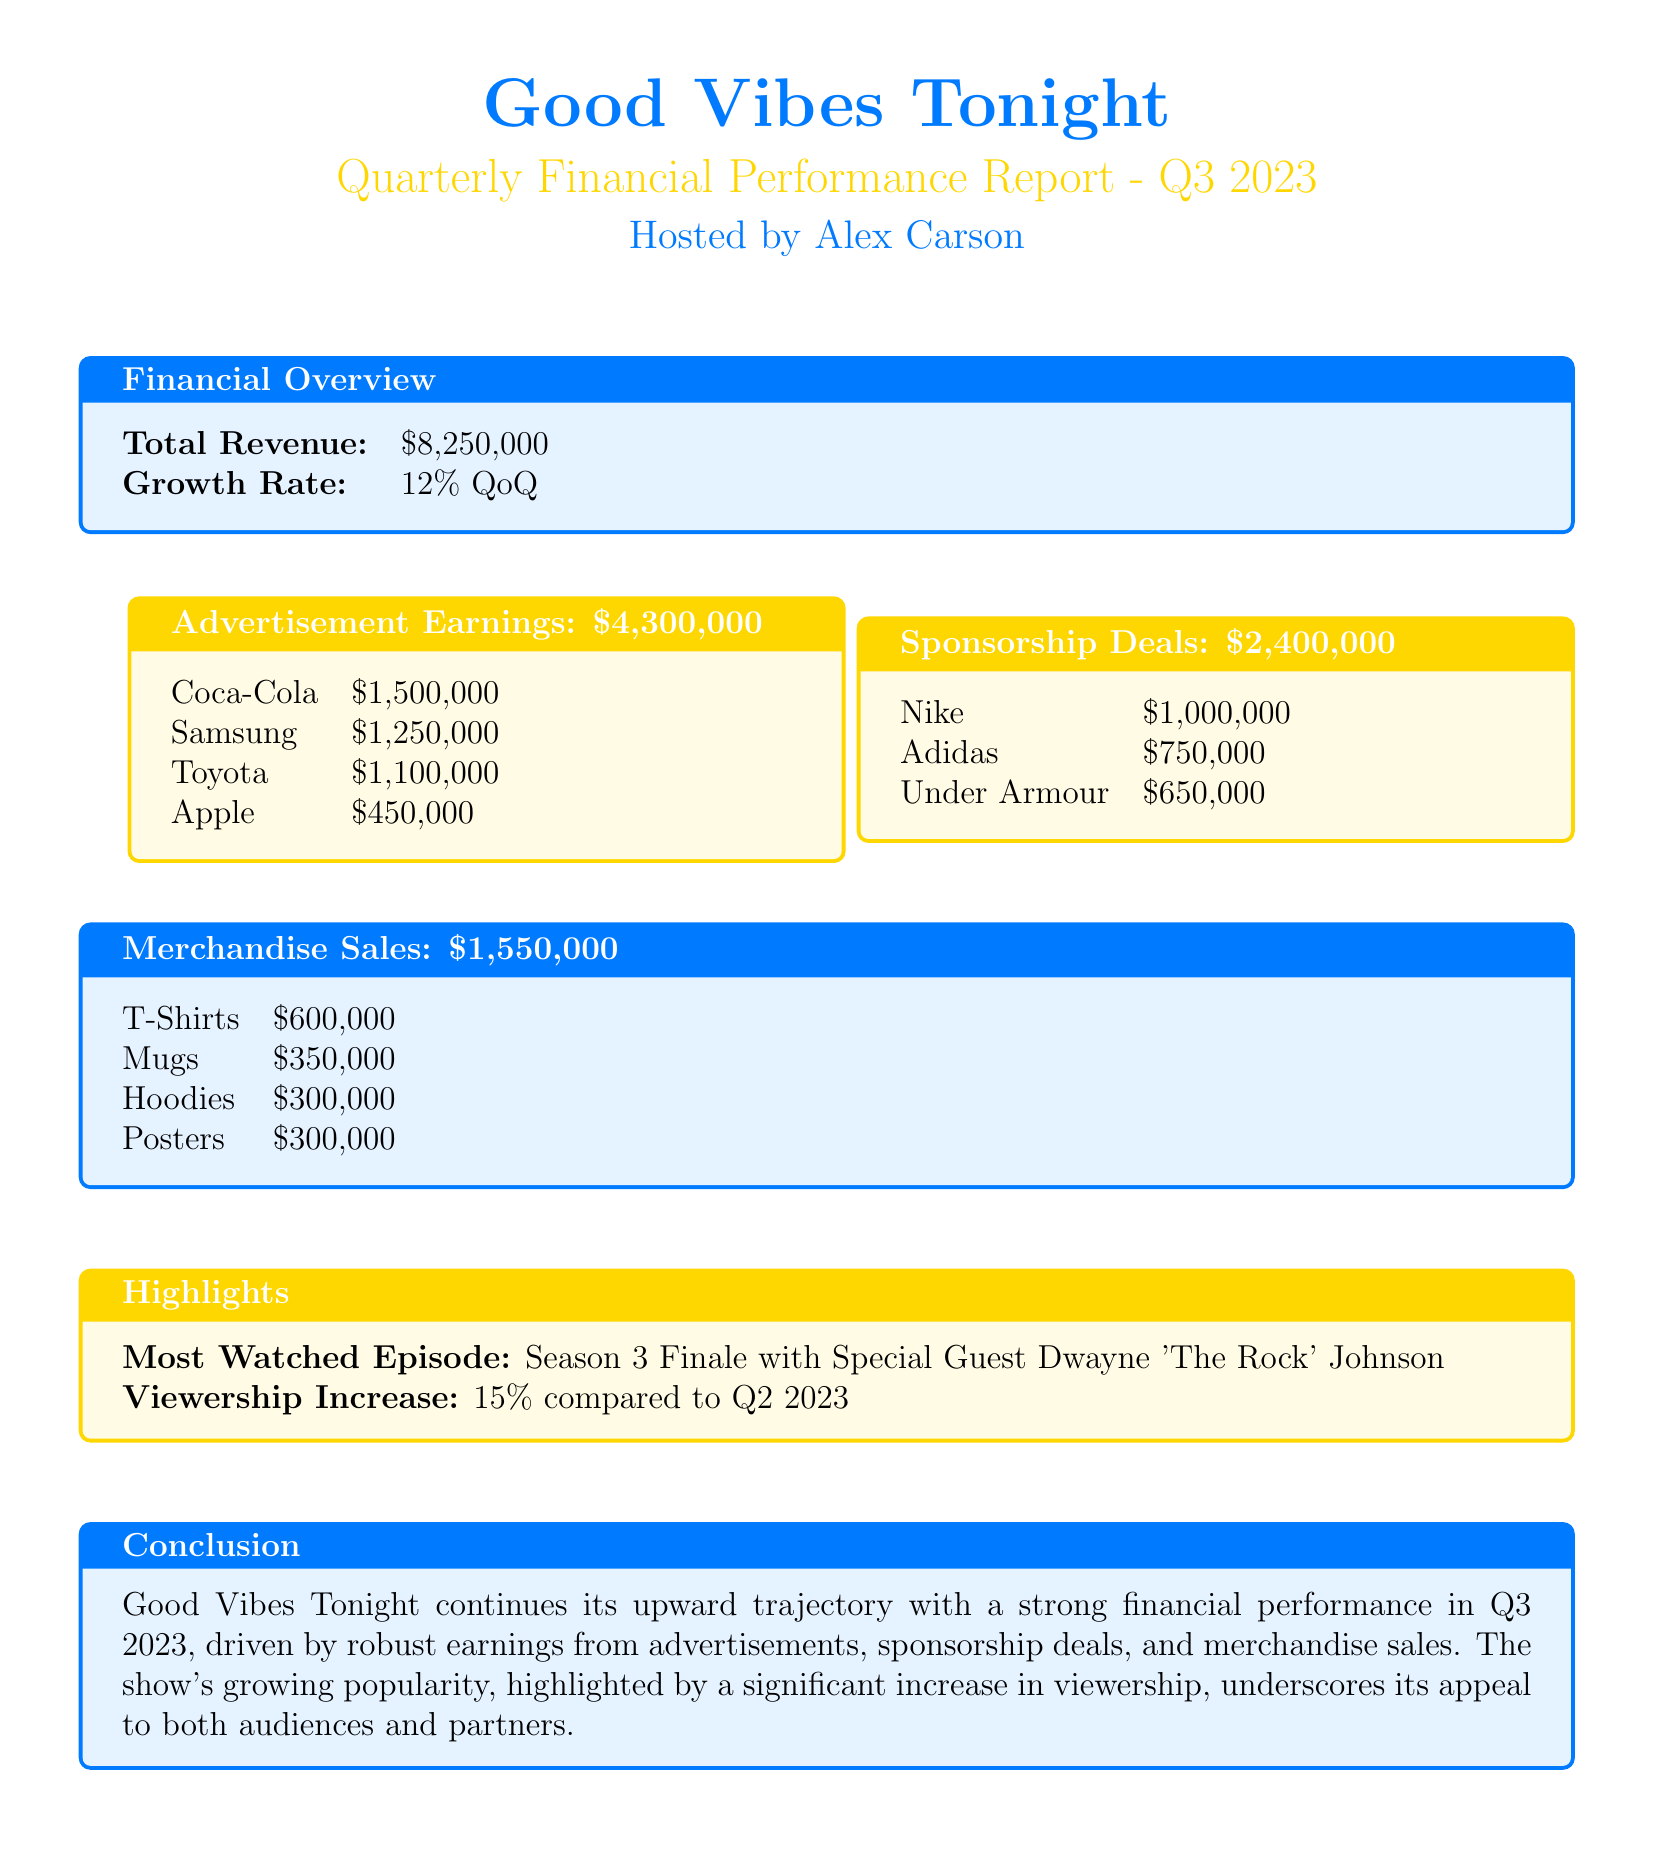What is the total revenue? The total revenue is provided in the financial overview section of the document.
Answer: $8,250,000 What was the growth rate for Q3 2023? The growth rate is mentioned alongside the total revenue in the financial overview section.
Answer: 12% QoQ How much did Coca-Cola contribute to advertisement earnings? Coca-Cola's contribution is listed in the advertisement earnings section.
Answer: $1,500,000 Which sponsorship deal generated the most revenue? The highest revenue sponsorship deal is noted in the sponsorship deals box.
Answer: Nike What is the total amount earned from merchandise sales? The total earnings from merchandise sales is indicated in the merchandise sales section.
Answer: $1,550,000 How much more did we earn from advertisements compared to merchandise sales? This requires calculating the difference between advertisement earnings and merchandise sales.
Answer: $2,750,000 What is the most watched episode mentioned in the highlights? The most watched episode is specified in the highlights section of the document.
Answer: Season 3 Finale with Special Guest Dwayne 'The Rock' Johnson What percentage increase in viewership was reported compared to Q2 2023? The document states the viewership increase in the highlights section.
Answer: 15% Which merchandise category earned the least? The least earning merchandise is identified in the merchandise sales breakdown.
Answer: Posters 